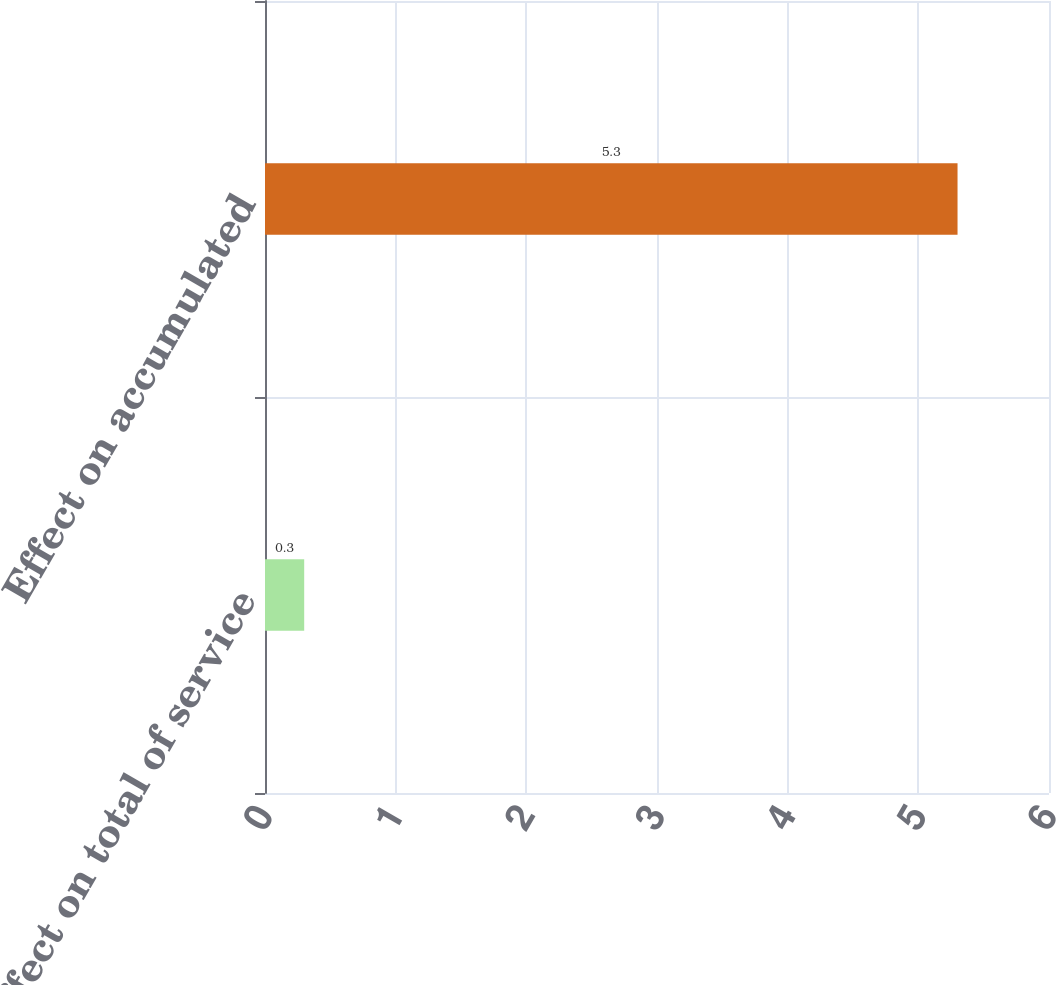Convert chart to OTSL. <chart><loc_0><loc_0><loc_500><loc_500><bar_chart><fcel>Effect on total of service<fcel>Effect on accumulated<nl><fcel>0.3<fcel>5.3<nl></chart> 